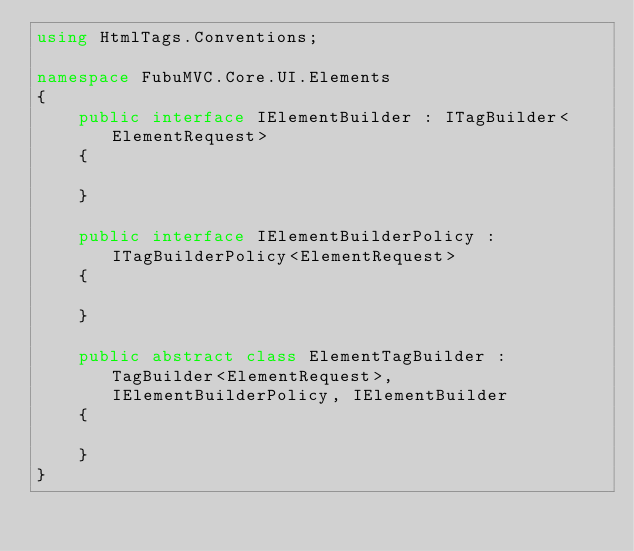Convert code to text. <code><loc_0><loc_0><loc_500><loc_500><_C#_>using HtmlTags.Conventions;

namespace FubuMVC.Core.UI.Elements
{
    public interface IElementBuilder : ITagBuilder<ElementRequest>
    {
        
    }

    public interface IElementBuilderPolicy : ITagBuilderPolicy<ElementRequest>
    {
        
    }

    public abstract class ElementTagBuilder : TagBuilder<ElementRequest>, IElementBuilderPolicy, IElementBuilder
    {
        
    }
}</code> 